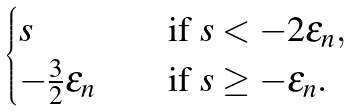Convert formula to latex. <formula><loc_0><loc_0><loc_500><loc_500>\begin{cases} s \quad & \text {if} \ s < - 2 \varepsilon _ { n } , \\ - \frac { 3 } { 2 } \epsilon _ { n } \quad & \text {if} \ s \geq - \varepsilon _ { n } . \end{cases}</formula> 